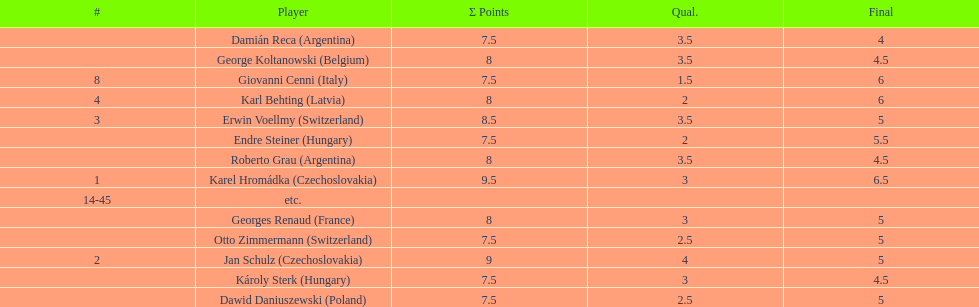Which player had the largest number of &#931; points? Karel Hromádka. 